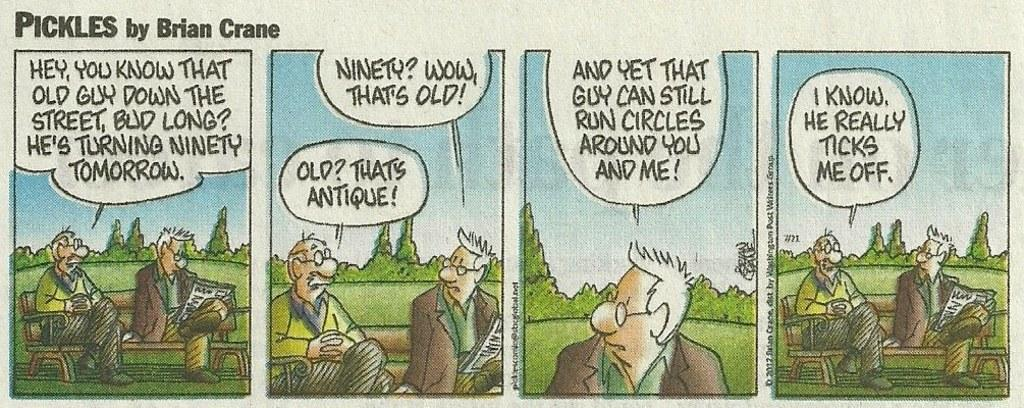What can be seen hanging on the wall in the image? There is a poster in the image. What are the people in the image doing? There are persons sitting on benches in the image. What can be seen in the background of the image besides the sky? There is text visible in the background of the image. What is the condition of the sky in the image? The sky is visible in the background of the image, and clouds are present. What type of insurance policy is being discussed by the persons sitting on the benches in the image? There is no indication in the image that the persons sitting on the benches are discussing any insurance policy. What part of the body is being balanced on the poster in the image? There is no poster depicting a body part being balanced in the image. 